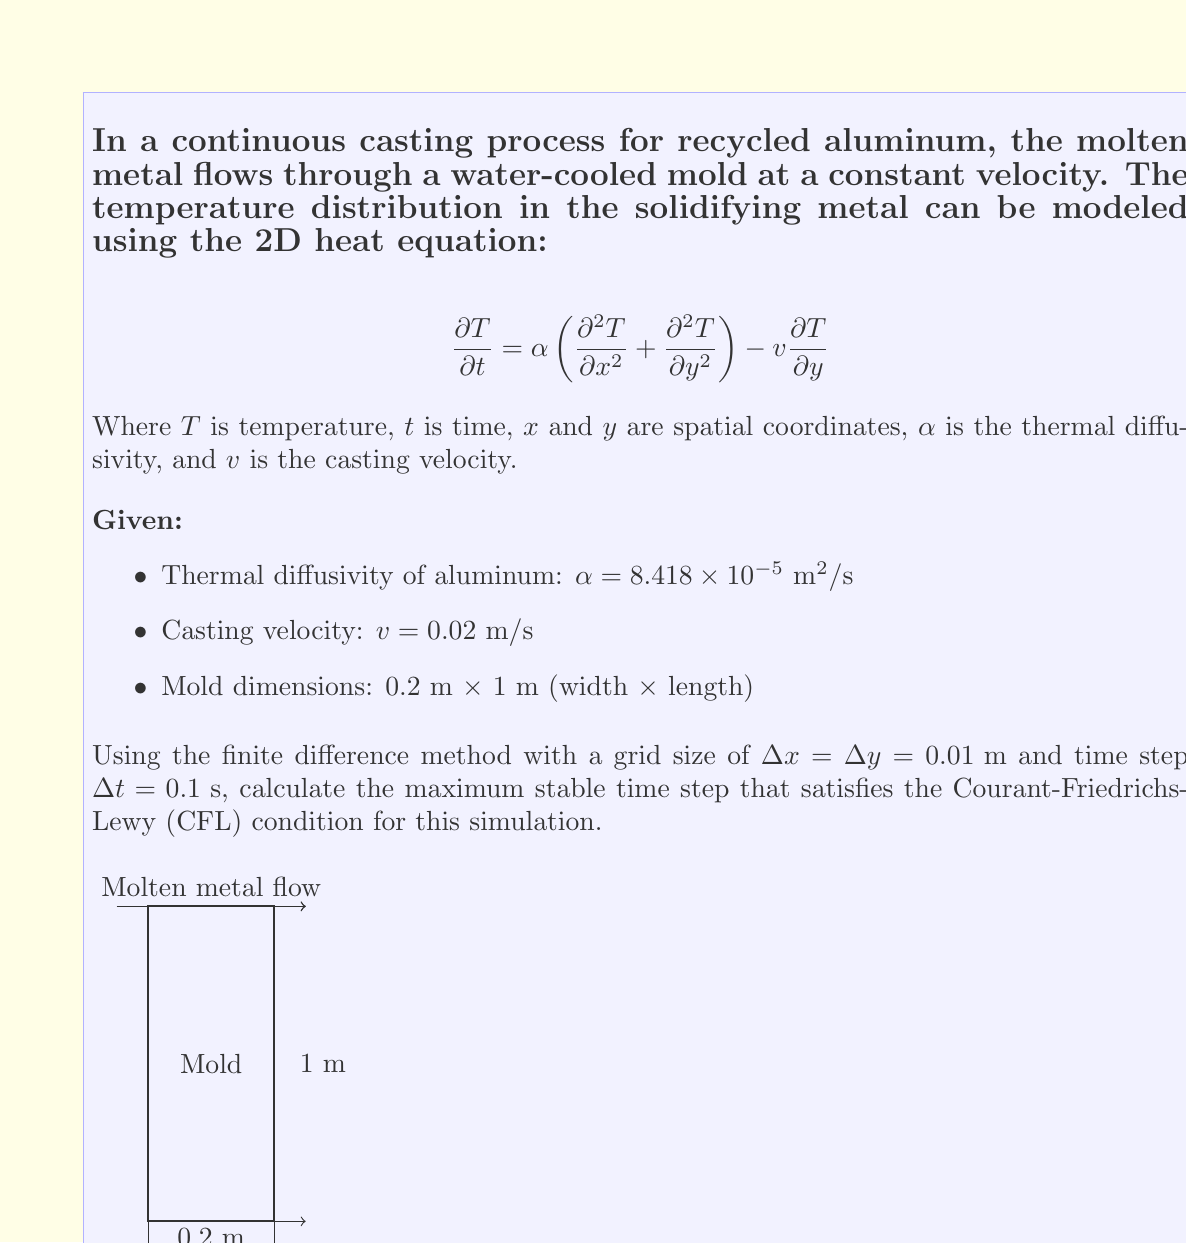Give your solution to this math problem. To find the maximum stable time step, we need to apply the Courant-Friedrichs-Lewy (CFL) condition for the 2D heat equation with advection. The steps are as follows:

1) The CFL condition for this type of equation is:

   $$\Delta t \leq \frac{1}{2\alpha\left(\frac{1}{\Delta x^2} + \frac{1}{\Delta y^2}\right) + \frac{v}{\Delta y}}$$

2) We are given:
   $\alpha = 8.418 \times 10^{-5} \text{ m}^2/\text{s}$
   $v = 0.02 \text{ m/s}$
   $\Delta x = \Delta y = 0.01 \text{ m}$

3) Substituting these values into the inequality:

   $$\Delta t \leq \frac{1}{2(8.418 \times 10^{-5})\left(\frac{1}{0.01^2} + \frac{1}{0.01^2}\right) + \frac{0.02}{0.01}}$$

4) Simplify:
   $$\Delta t \leq \frac{1}{2(8.418 \times 10^{-5})(20000) + 2}$$

5) Calculate:
   $$\Delta t \leq \frac{1}{3.3672 + 2} = \frac{1}{5.3672}$$

6) Evaluate:
   $$\Delta t \leq 0.1863 \text{ s}$$

7) The given time step of 0.1 s satisfies this condition, as $0.1 \text{ s} < 0.1863 \text{ s}$.

Therefore, the maximum stable time step is 0.1863 s.
Answer: 0.1863 s 